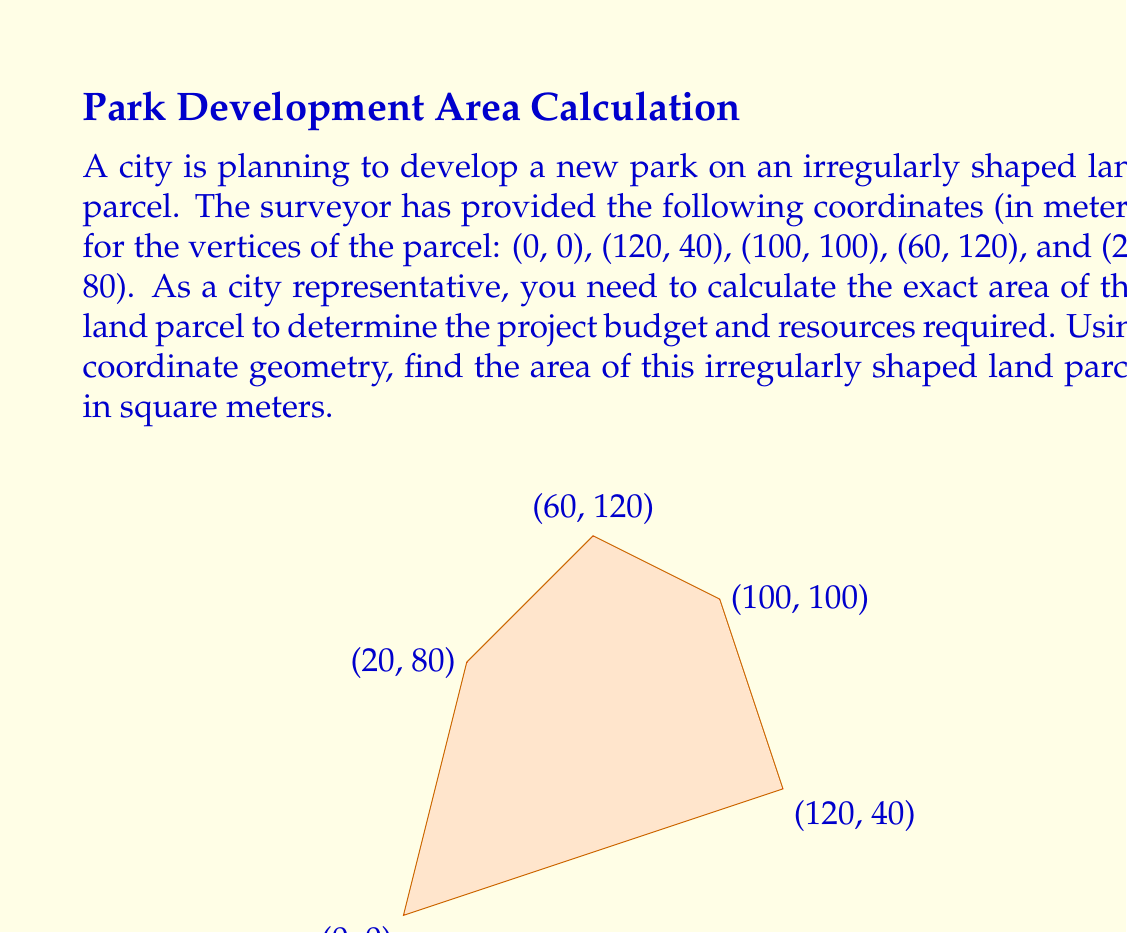Could you help me with this problem? To calculate the area of an irregularly shaped polygon given its vertices' coordinates, we can use the Shoelace formula (also known as the surveyor's formula). This method is particularly useful for city planning and land development projects.

The Shoelace formula for a polygon with n vertices $(x_1, y_1), (x_2, y_2), ..., (x_n, y_n)$ is:

$$\text{Area} = \frac{1}{2}|(x_1y_2 + x_2y_3 + ... + x_ny_1) - (y_1x_2 + y_2x_3 + ... + y_nx_1)|$$

Let's apply this formula to our land parcel:

1) First, let's organize our vertices:
   $(x_1, y_1) = (0, 0)$
   $(x_2, y_2) = (120, 40)$
   $(x_3, y_3) = (100, 100)$
   $(x_4, y_4) = (60, 120)$
   $(x_5, y_5) = (20, 80)$

2) Now, let's calculate the two sums in the formula:

   Sum 1: $x_1y_2 + x_2y_3 + x_3y_4 + x_4y_5 + x_5y_1$
   $= (0 \times 40) + (120 \times 100) + (100 \times 120) + (60 \times 80) + (20 \times 0)$
   $= 0 + 12000 + 12000 + 4800 + 0 = 28800$

   Sum 2: $y_1x_2 + y_2x_3 + y_3x_4 + y_4x_5 + y_5x_1$
   $= (0 \times 120) + (40 \times 100) + (100 \times 60) + (120 \times 20) + (80 \times 0)$
   $= 0 + 4000 + 6000 + 2400 + 0 = 12400$

3) Subtracting Sum 2 from Sum 1:
   $28800 - 12400 = 16400$

4) Taking the absolute value and dividing by 2:
   $\frac{1}{2}|16400| = 8200$

Therefore, the area of the land parcel is 8200 square meters.
Answer: The area of the irregularly shaped land parcel is 8200 square meters. 